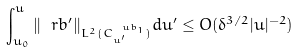<formula> <loc_0><loc_0><loc_500><loc_500>\int _ { u _ { 0 } } ^ { u } \| \ r b ^ { \prime } \| _ { L ^ { 2 } ( C ^ { \ u b _ { 1 } } _ { u ^ { \prime } } ) } d u ^ { \prime } \leq O ( \delta ^ { 3 / 2 } | u | ^ { - 2 } )</formula> 